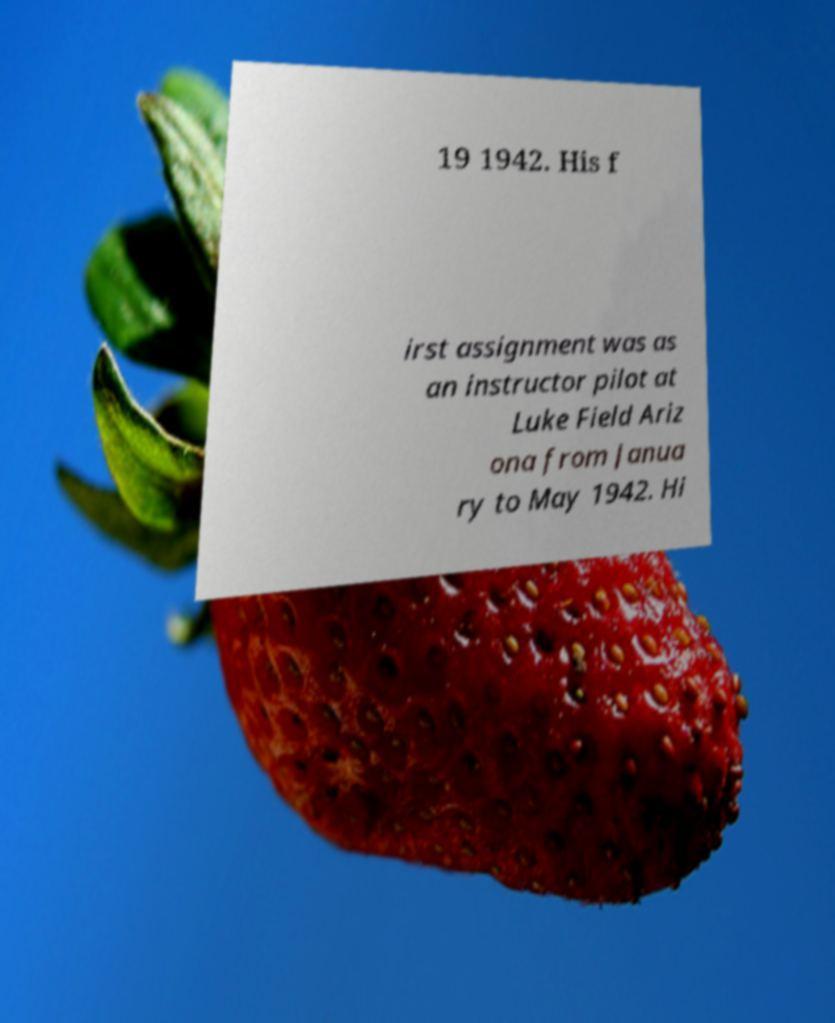For documentation purposes, I need the text within this image transcribed. Could you provide that? 19 1942. His f irst assignment was as an instructor pilot at Luke Field Ariz ona from Janua ry to May 1942. Hi 